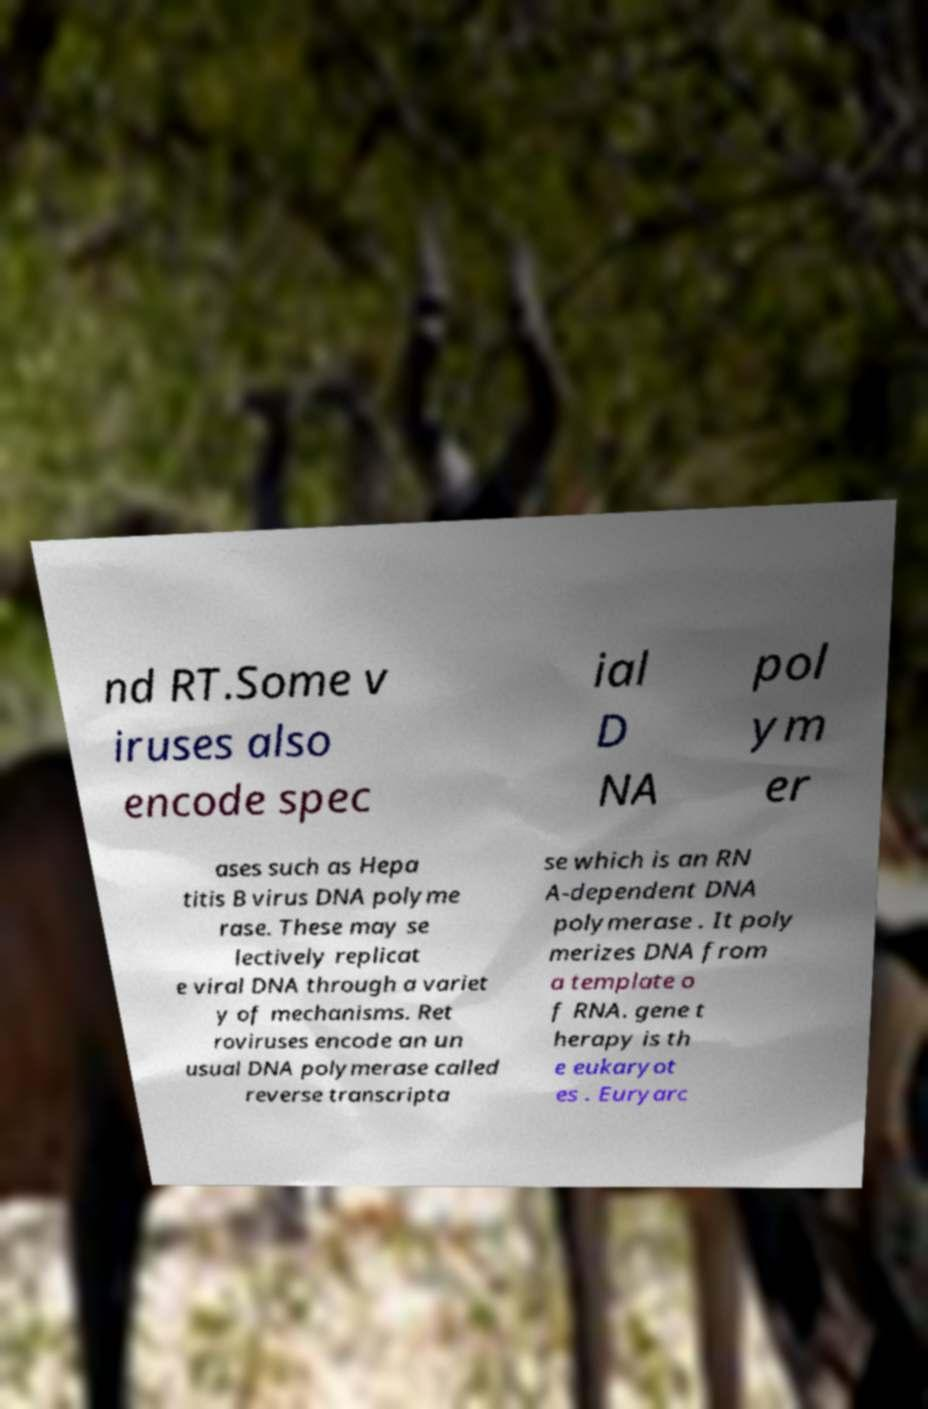Could you extract and type out the text from this image? nd RT.Some v iruses also encode spec ial D NA pol ym er ases such as Hepa titis B virus DNA polyme rase. These may se lectively replicat e viral DNA through a variet y of mechanisms. Ret roviruses encode an un usual DNA polymerase called reverse transcripta se which is an RN A-dependent DNA polymerase . It poly merizes DNA from a template o f RNA. gene t herapy is th e eukaryot es . Euryarc 